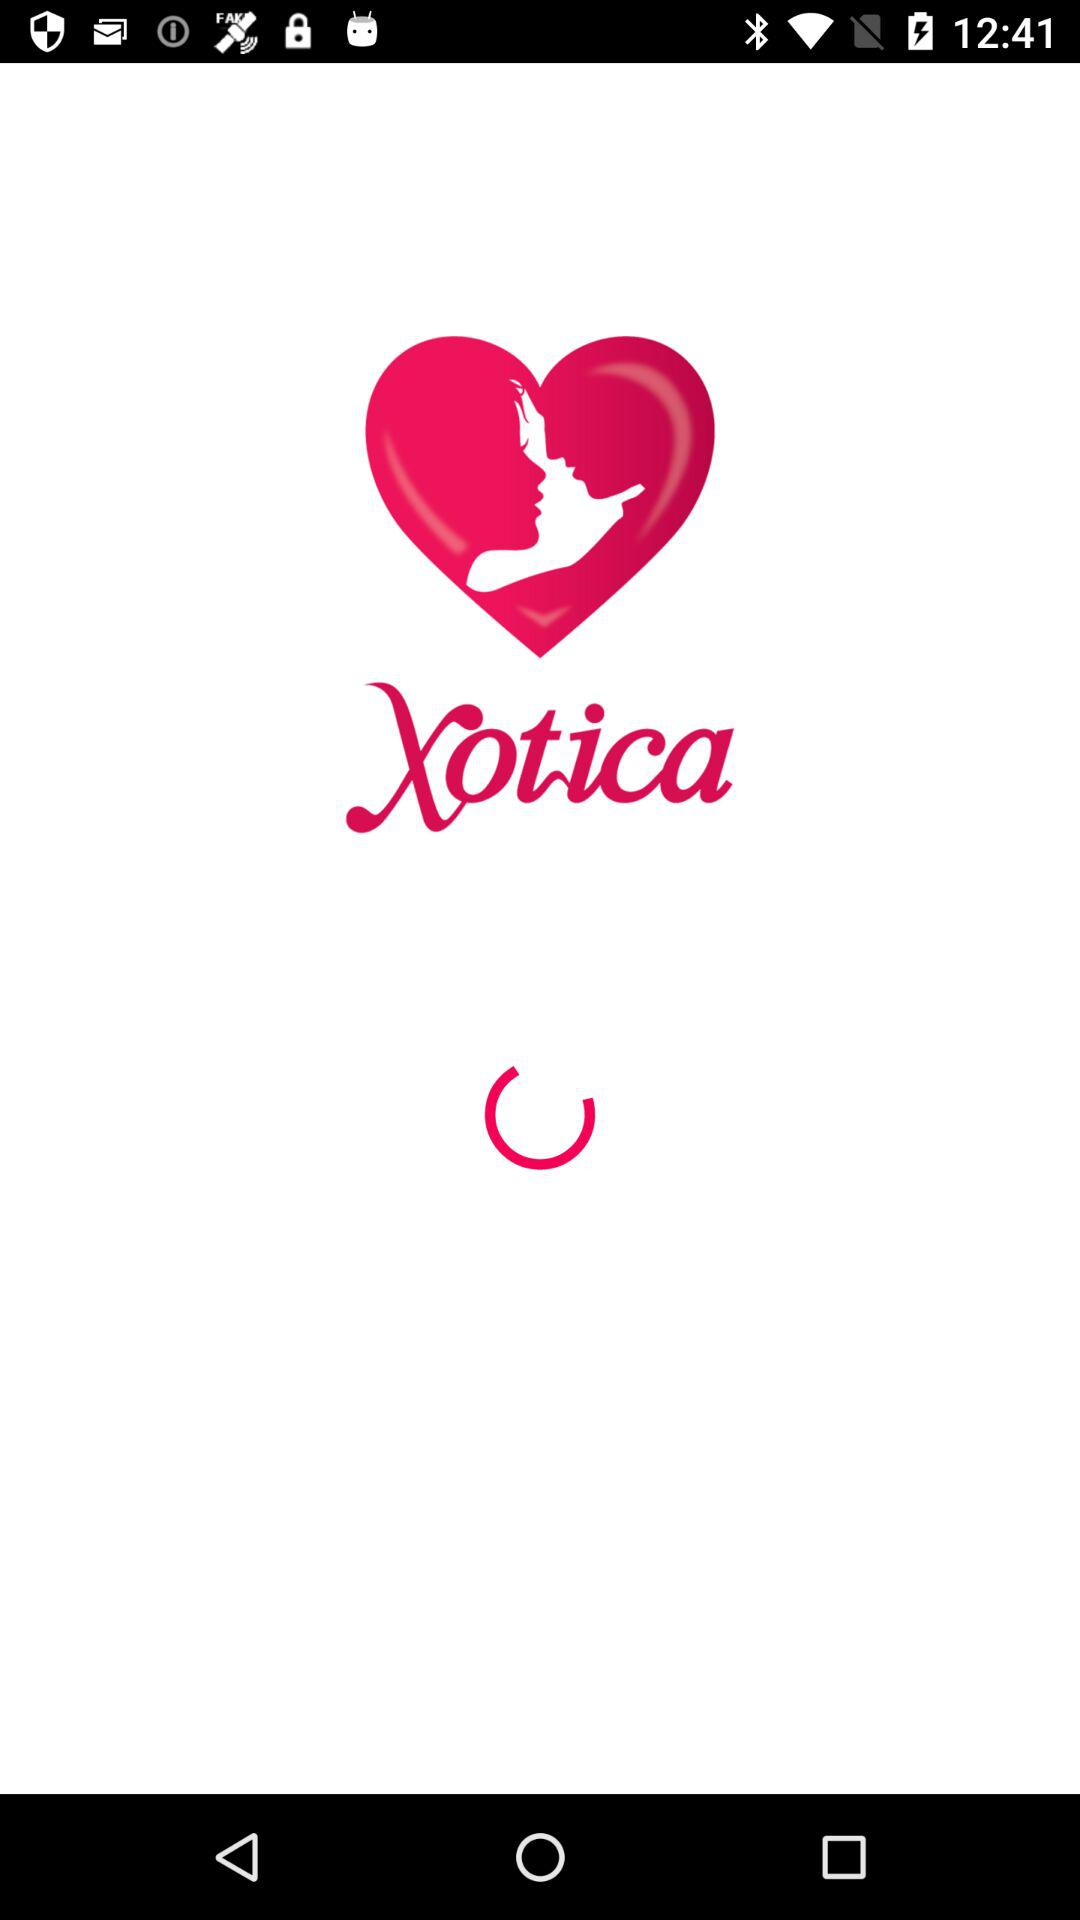What is the application name? The application name is "Xotica". 